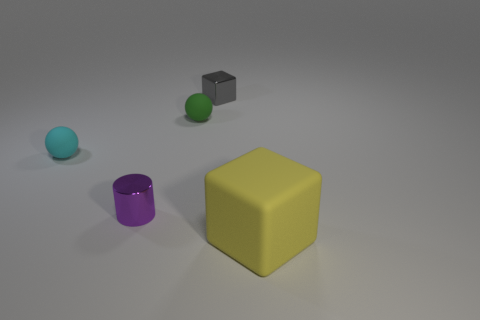How many big objects are behind the big yellow block?
Give a very brief answer. 0. Is there a small metal cube?
Offer a terse response. Yes. There is a rubber ball that is right of the metal thing in front of the tiny matte object that is left of the tiny purple object; how big is it?
Provide a short and direct response. Small. How many other objects are there of the same size as the cyan sphere?
Offer a terse response. 3. There is a metal thing that is in front of the small gray shiny cube; what is its size?
Give a very brief answer. Small. Are there any other things that have the same color as the rubber block?
Offer a terse response. No. Does the cube behind the yellow block have the same material as the yellow object?
Keep it short and to the point. No. How many matte things are in front of the tiny green rubber thing and to the left of the tiny gray metallic object?
Keep it short and to the point. 1. What is the size of the matte sphere on the right side of the tiny matte sphere in front of the green sphere?
Your answer should be compact. Small. Is there any other thing that is the same material as the gray cube?
Make the answer very short. Yes. 